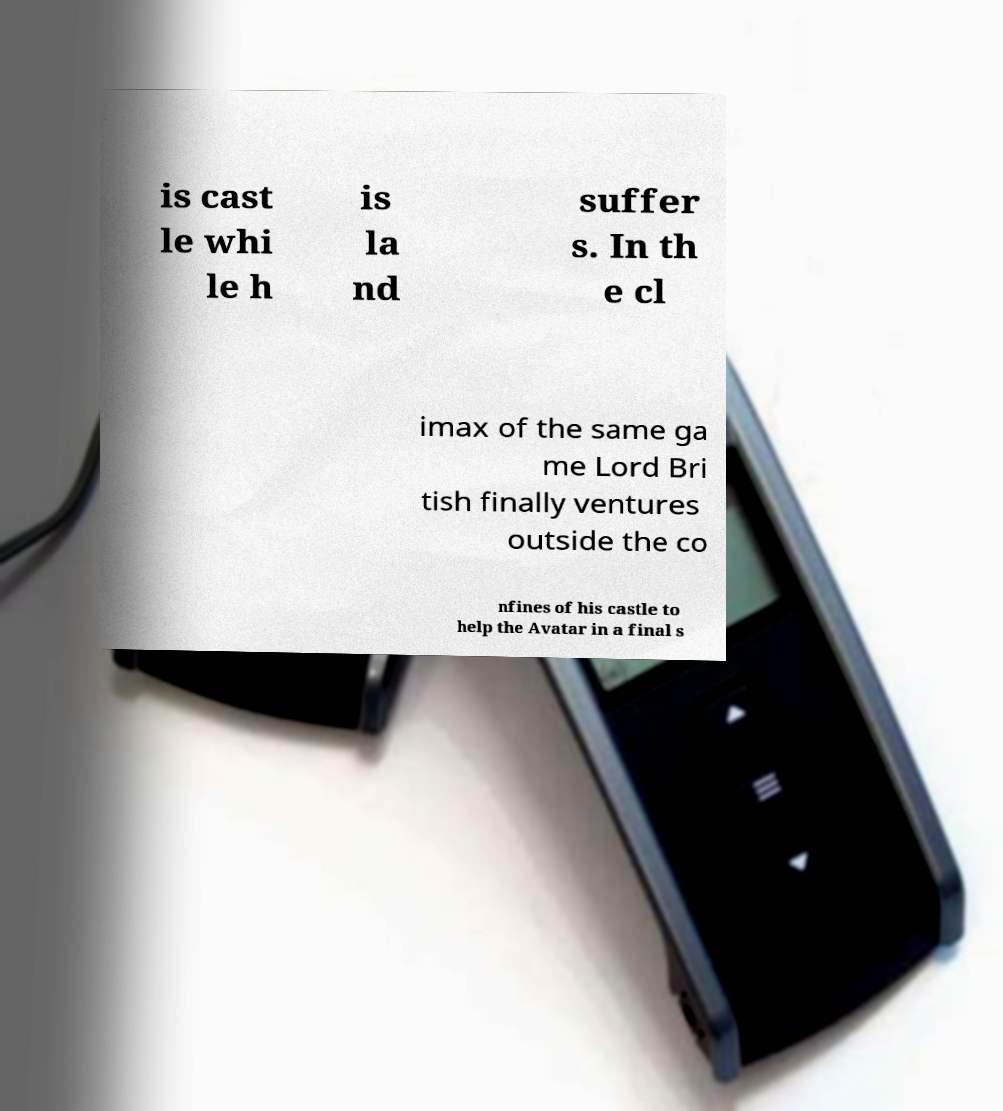Can you read and provide the text displayed in the image?This photo seems to have some interesting text. Can you extract and type it out for me? is cast le whi le h is la nd suffer s. In th e cl imax of the same ga me Lord Bri tish finally ventures outside the co nfines of his castle to help the Avatar in a final s 